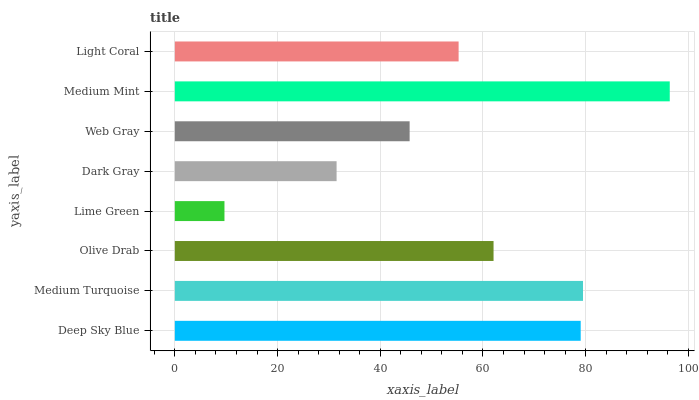Is Lime Green the minimum?
Answer yes or no. Yes. Is Medium Mint the maximum?
Answer yes or no. Yes. Is Medium Turquoise the minimum?
Answer yes or no. No. Is Medium Turquoise the maximum?
Answer yes or no. No. Is Medium Turquoise greater than Deep Sky Blue?
Answer yes or no. Yes. Is Deep Sky Blue less than Medium Turquoise?
Answer yes or no. Yes. Is Deep Sky Blue greater than Medium Turquoise?
Answer yes or no. No. Is Medium Turquoise less than Deep Sky Blue?
Answer yes or no. No. Is Olive Drab the high median?
Answer yes or no. Yes. Is Light Coral the low median?
Answer yes or no. Yes. Is Deep Sky Blue the high median?
Answer yes or no. No. Is Medium Mint the low median?
Answer yes or no. No. 